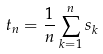Convert formula to latex. <formula><loc_0><loc_0><loc_500><loc_500>t _ { n } = \frac { 1 } { n } \sum _ { k = 1 } ^ { n } s _ { k }</formula> 